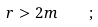<formula> <loc_0><loc_0><loc_500><loc_500>r > 2 m \quad ;</formula> 